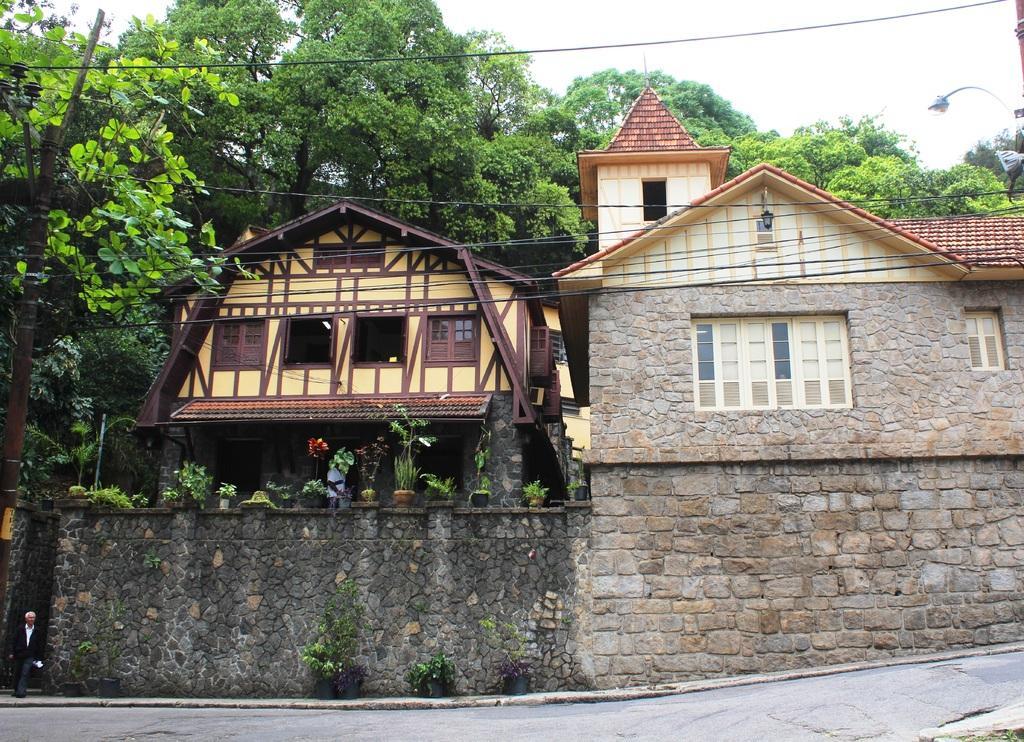Can you describe this image briefly? In this picture I can see the building and shed. In the background I can see many trees. On the right there is a street light. At the bottom there is a road. At the top I can see the sky. On the bottom left corner there is a man who is standing near to the wall. 